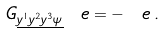<formula> <loc_0><loc_0><loc_500><loc_500>\ G _ { \underline { y ^ { 1 } y ^ { 2 } y ^ { 3 } \psi } } \ e = - \ e \, .</formula> 